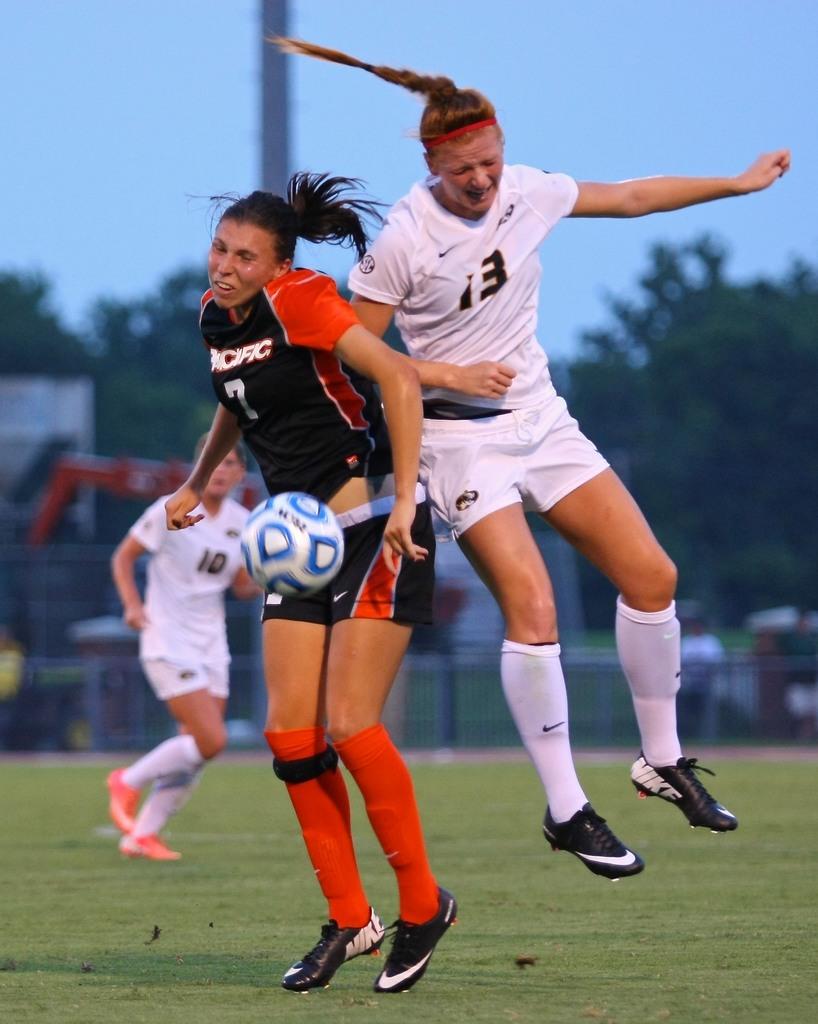Did 13 run into 7?
Your answer should be compact. Yes. What number is on the white jersey?
Make the answer very short. 13. 